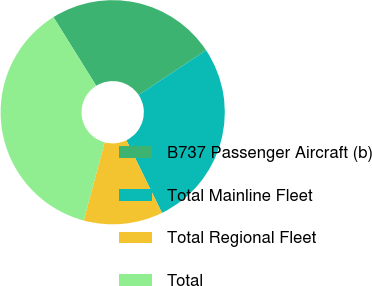Convert chart to OTSL. <chart><loc_0><loc_0><loc_500><loc_500><pie_chart><fcel>B737 Passenger Aircraft (b)<fcel>Total Mainline Fleet<fcel>Total Regional Fleet<fcel>Total<nl><fcel>24.53%<fcel>27.09%<fcel>11.41%<fcel>36.97%<nl></chart> 